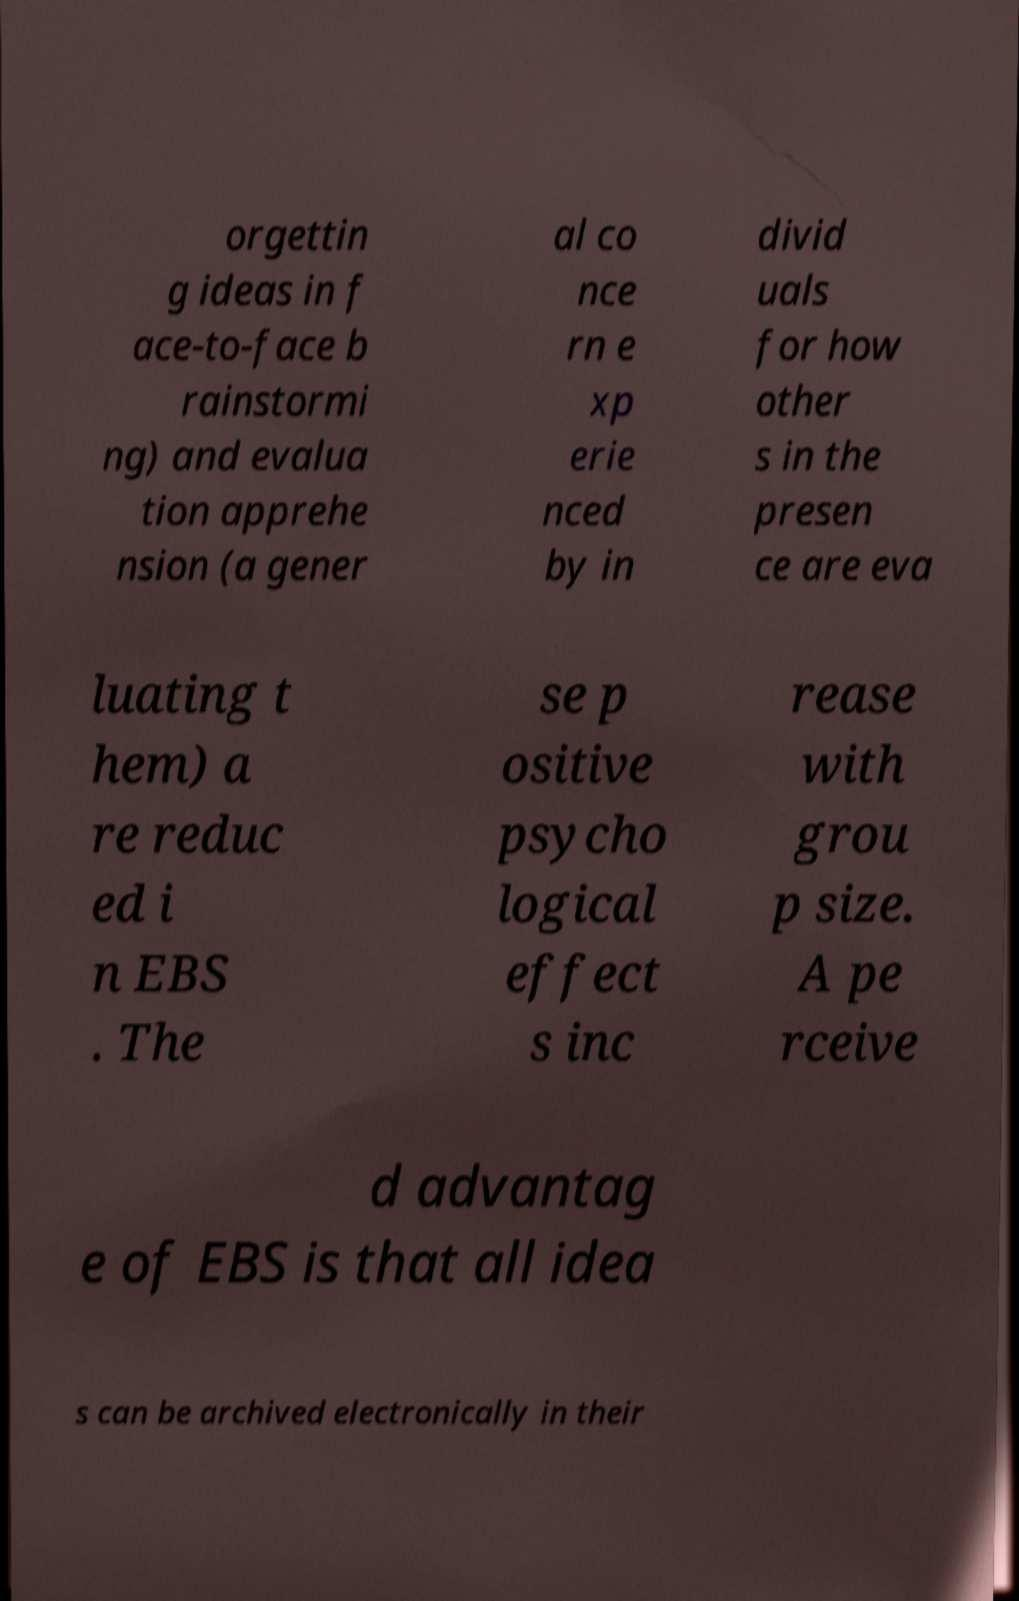Please read and relay the text visible in this image. What does it say? orgettin g ideas in f ace-to-face b rainstormi ng) and evalua tion apprehe nsion (a gener al co nce rn e xp erie nced by in divid uals for how other s in the presen ce are eva luating t hem) a re reduc ed i n EBS . The se p ositive psycho logical effect s inc rease with grou p size. A pe rceive d advantag e of EBS is that all idea s can be archived electronically in their 